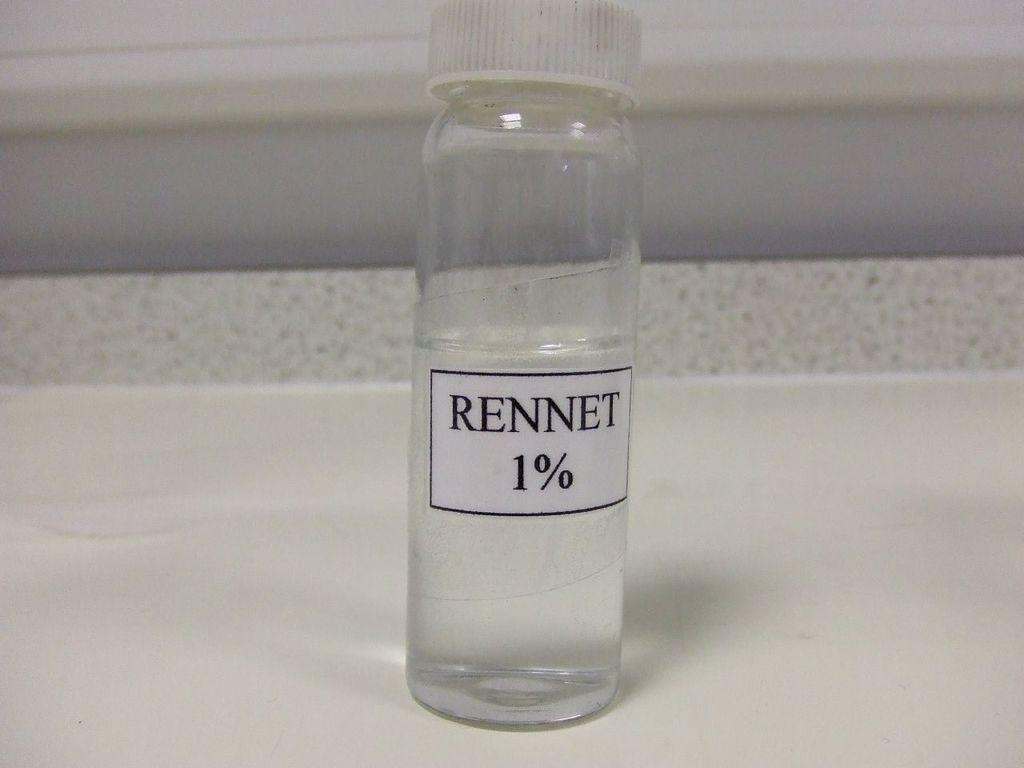<image>
Present a compact description of the photo's key features. A small bottle of liquid that has the label "Rennet 1%" on it. 